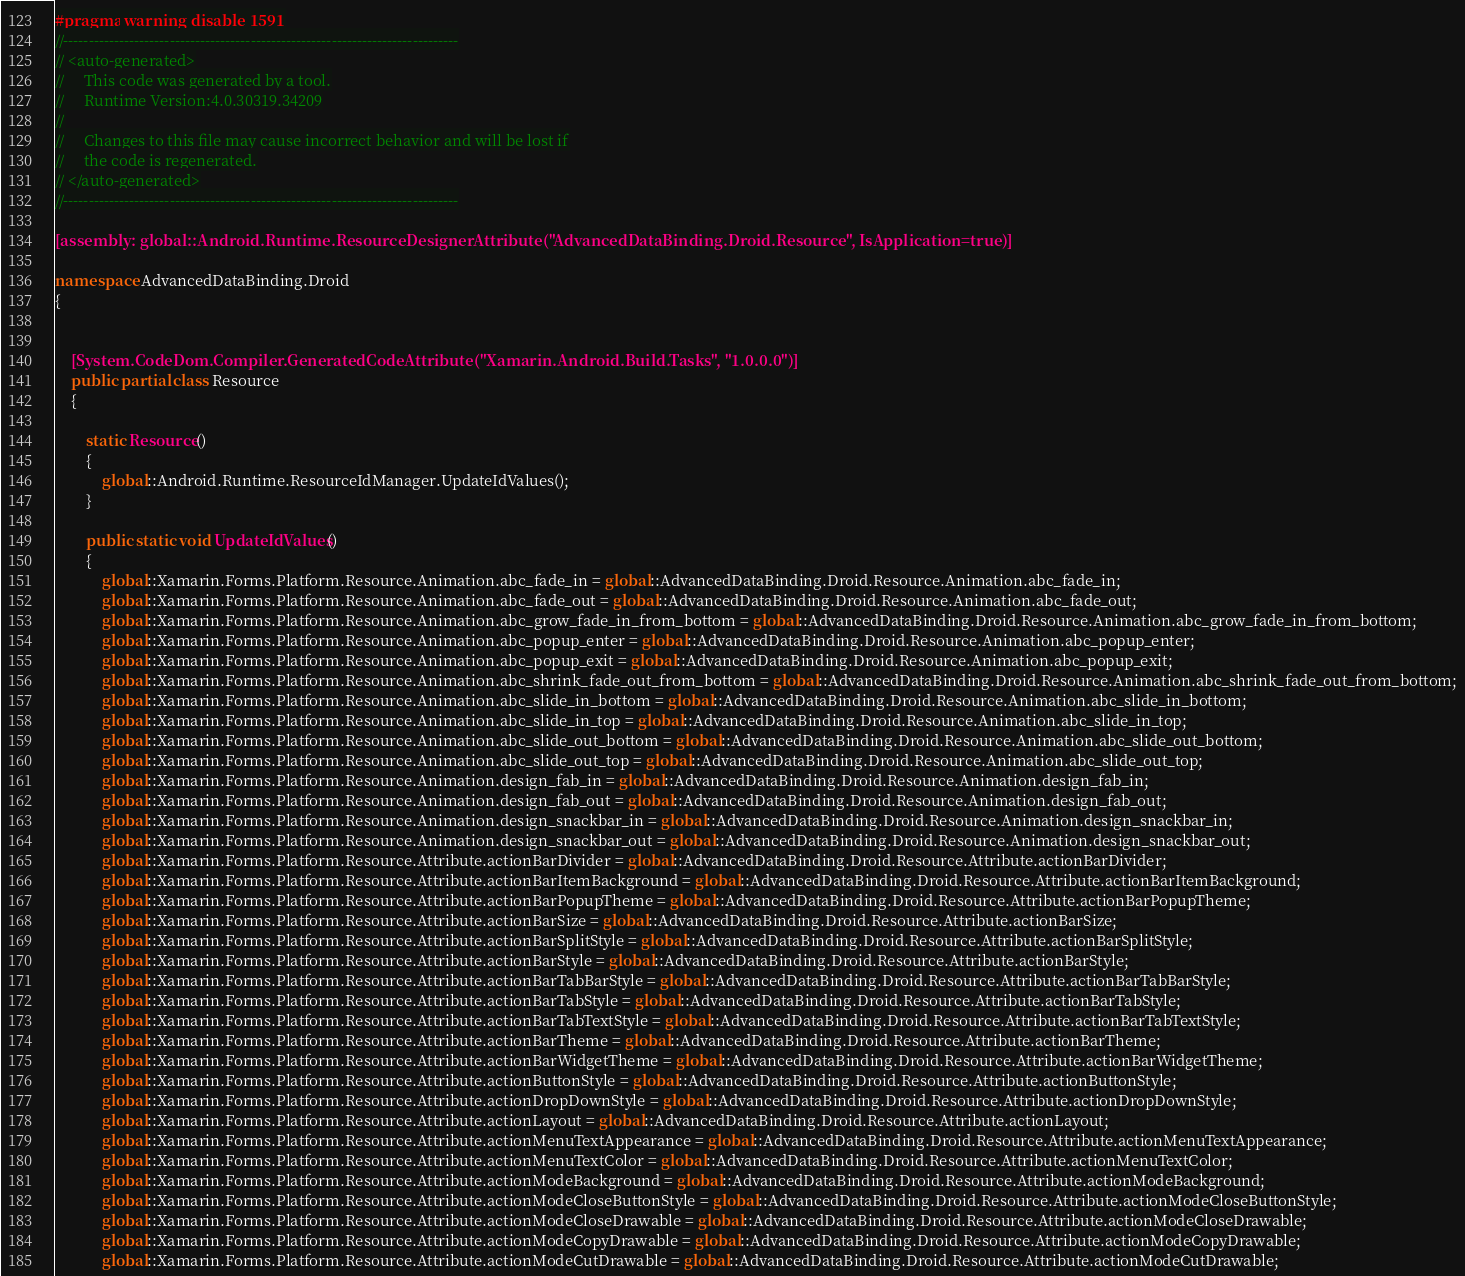Convert code to text. <code><loc_0><loc_0><loc_500><loc_500><_C#_>#pragma warning disable 1591
//------------------------------------------------------------------------------
// <auto-generated>
//     This code was generated by a tool.
//     Runtime Version:4.0.30319.34209
//
//     Changes to this file may cause incorrect behavior and will be lost if
//     the code is regenerated.
// </auto-generated>
//------------------------------------------------------------------------------

[assembly: global::Android.Runtime.ResourceDesignerAttribute("AdvancedDataBinding.Droid.Resource", IsApplication=true)]

namespace AdvancedDataBinding.Droid
{
	
	
	[System.CodeDom.Compiler.GeneratedCodeAttribute("Xamarin.Android.Build.Tasks", "1.0.0.0")]
	public partial class Resource
	{
		
		static Resource()
		{
			global::Android.Runtime.ResourceIdManager.UpdateIdValues();
		}
		
		public static void UpdateIdValues()
		{
			global::Xamarin.Forms.Platform.Resource.Animation.abc_fade_in = global::AdvancedDataBinding.Droid.Resource.Animation.abc_fade_in;
			global::Xamarin.Forms.Platform.Resource.Animation.abc_fade_out = global::AdvancedDataBinding.Droid.Resource.Animation.abc_fade_out;
			global::Xamarin.Forms.Platform.Resource.Animation.abc_grow_fade_in_from_bottom = global::AdvancedDataBinding.Droid.Resource.Animation.abc_grow_fade_in_from_bottom;
			global::Xamarin.Forms.Platform.Resource.Animation.abc_popup_enter = global::AdvancedDataBinding.Droid.Resource.Animation.abc_popup_enter;
			global::Xamarin.Forms.Platform.Resource.Animation.abc_popup_exit = global::AdvancedDataBinding.Droid.Resource.Animation.abc_popup_exit;
			global::Xamarin.Forms.Platform.Resource.Animation.abc_shrink_fade_out_from_bottom = global::AdvancedDataBinding.Droid.Resource.Animation.abc_shrink_fade_out_from_bottom;
			global::Xamarin.Forms.Platform.Resource.Animation.abc_slide_in_bottom = global::AdvancedDataBinding.Droid.Resource.Animation.abc_slide_in_bottom;
			global::Xamarin.Forms.Platform.Resource.Animation.abc_slide_in_top = global::AdvancedDataBinding.Droid.Resource.Animation.abc_slide_in_top;
			global::Xamarin.Forms.Platform.Resource.Animation.abc_slide_out_bottom = global::AdvancedDataBinding.Droid.Resource.Animation.abc_slide_out_bottom;
			global::Xamarin.Forms.Platform.Resource.Animation.abc_slide_out_top = global::AdvancedDataBinding.Droid.Resource.Animation.abc_slide_out_top;
			global::Xamarin.Forms.Platform.Resource.Animation.design_fab_in = global::AdvancedDataBinding.Droid.Resource.Animation.design_fab_in;
			global::Xamarin.Forms.Platform.Resource.Animation.design_fab_out = global::AdvancedDataBinding.Droid.Resource.Animation.design_fab_out;
			global::Xamarin.Forms.Platform.Resource.Animation.design_snackbar_in = global::AdvancedDataBinding.Droid.Resource.Animation.design_snackbar_in;
			global::Xamarin.Forms.Platform.Resource.Animation.design_snackbar_out = global::AdvancedDataBinding.Droid.Resource.Animation.design_snackbar_out;
			global::Xamarin.Forms.Platform.Resource.Attribute.actionBarDivider = global::AdvancedDataBinding.Droid.Resource.Attribute.actionBarDivider;
			global::Xamarin.Forms.Platform.Resource.Attribute.actionBarItemBackground = global::AdvancedDataBinding.Droid.Resource.Attribute.actionBarItemBackground;
			global::Xamarin.Forms.Platform.Resource.Attribute.actionBarPopupTheme = global::AdvancedDataBinding.Droid.Resource.Attribute.actionBarPopupTheme;
			global::Xamarin.Forms.Platform.Resource.Attribute.actionBarSize = global::AdvancedDataBinding.Droid.Resource.Attribute.actionBarSize;
			global::Xamarin.Forms.Platform.Resource.Attribute.actionBarSplitStyle = global::AdvancedDataBinding.Droid.Resource.Attribute.actionBarSplitStyle;
			global::Xamarin.Forms.Platform.Resource.Attribute.actionBarStyle = global::AdvancedDataBinding.Droid.Resource.Attribute.actionBarStyle;
			global::Xamarin.Forms.Platform.Resource.Attribute.actionBarTabBarStyle = global::AdvancedDataBinding.Droid.Resource.Attribute.actionBarTabBarStyle;
			global::Xamarin.Forms.Platform.Resource.Attribute.actionBarTabStyle = global::AdvancedDataBinding.Droid.Resource.Attribute.actionBarTabStyle;
			global::Xamarin.Forms.Platform.Resource.Attribute.actionBarTabTextStyle = global::AdvancedDataBinding.Droid.Resource.Attribute.actionBarTabTextStyle;
			global::Xamarin.Forms.Platform.Resource.Attribute.actionBarTheme = global::AdvancedDataBinding.Droid.Resource.Attribute.actionBarTheme;
			global::Xamarin.Forms.Platform.Resource.Attribute.actionBarWidgetTheme = global::AdvancedDataBinding.Droid.Resource.Attribute.actionBarWidgetTheme;
			global::Xamarin.Forms.Platform.Resource.Attribute.actionButtonStyle = global::AdvancedDataBinding.Droid.Resource.Attribute.actionButtonStyle;
			global::Xamarin.Forms.Platform.Resource.Attribute.actionDropDownStyle = global::AdvancedDataBinding.Droid.Resource.Attribute.actionDropDownStyle;
			global::Xamarin.Forms.Platform.Resource.Attribute.actionLayout = global::AdvancedDataBinding.Droid.Resource.Attribute.actionLayout;
			global::Xamarin.Forms.Platform.Resource.Attribute.actionMenuTextAppearance = global::AdvancedDataBinding.Droid.Resource.Attribute.actionMenuTextAppearance;
			global::Xamarin.Forms.Platform.Resource.Attribute.actionMenuTextColor = global::AdvancedDataBinding.Droid.Resource.Attribute.actionMenuTextColor;
			global::Xamarin.Forms.Platform.Resource.Attribute.actionModeBackground = global::AdvancedDataBinding.Droid.Resource.Attribute.actionModeBackground;
			global::Xamarin.Forms.Platform.Resource.Attribute.actionModeCloseButtonStyle = global::AdvancedDataBinding.Droid.Resource.Attribute.actionModeCloseButtonStyle;
			global::Xamarin.Forms.Platform.Resource.Attribute.actionModeCloseDrawable = global::AdvancedDataBinding.Droid.Resource.Attribute.actionModeCloseDrawable;
			global::Xamarin.Forms.Platform.Resource.Attribute.actionModeCopyDrawable = global::AdvancedDataBinding.Droid.Resource.Attribute.actionModeCopyDrawable;
			global::Xamarin.Forms.Platform.Resource.Attribute.actionModeCutDrawable = global::AdvancedDataBinding.Droid.Resource.Attribute.actionModeCutDrawable;</code> 